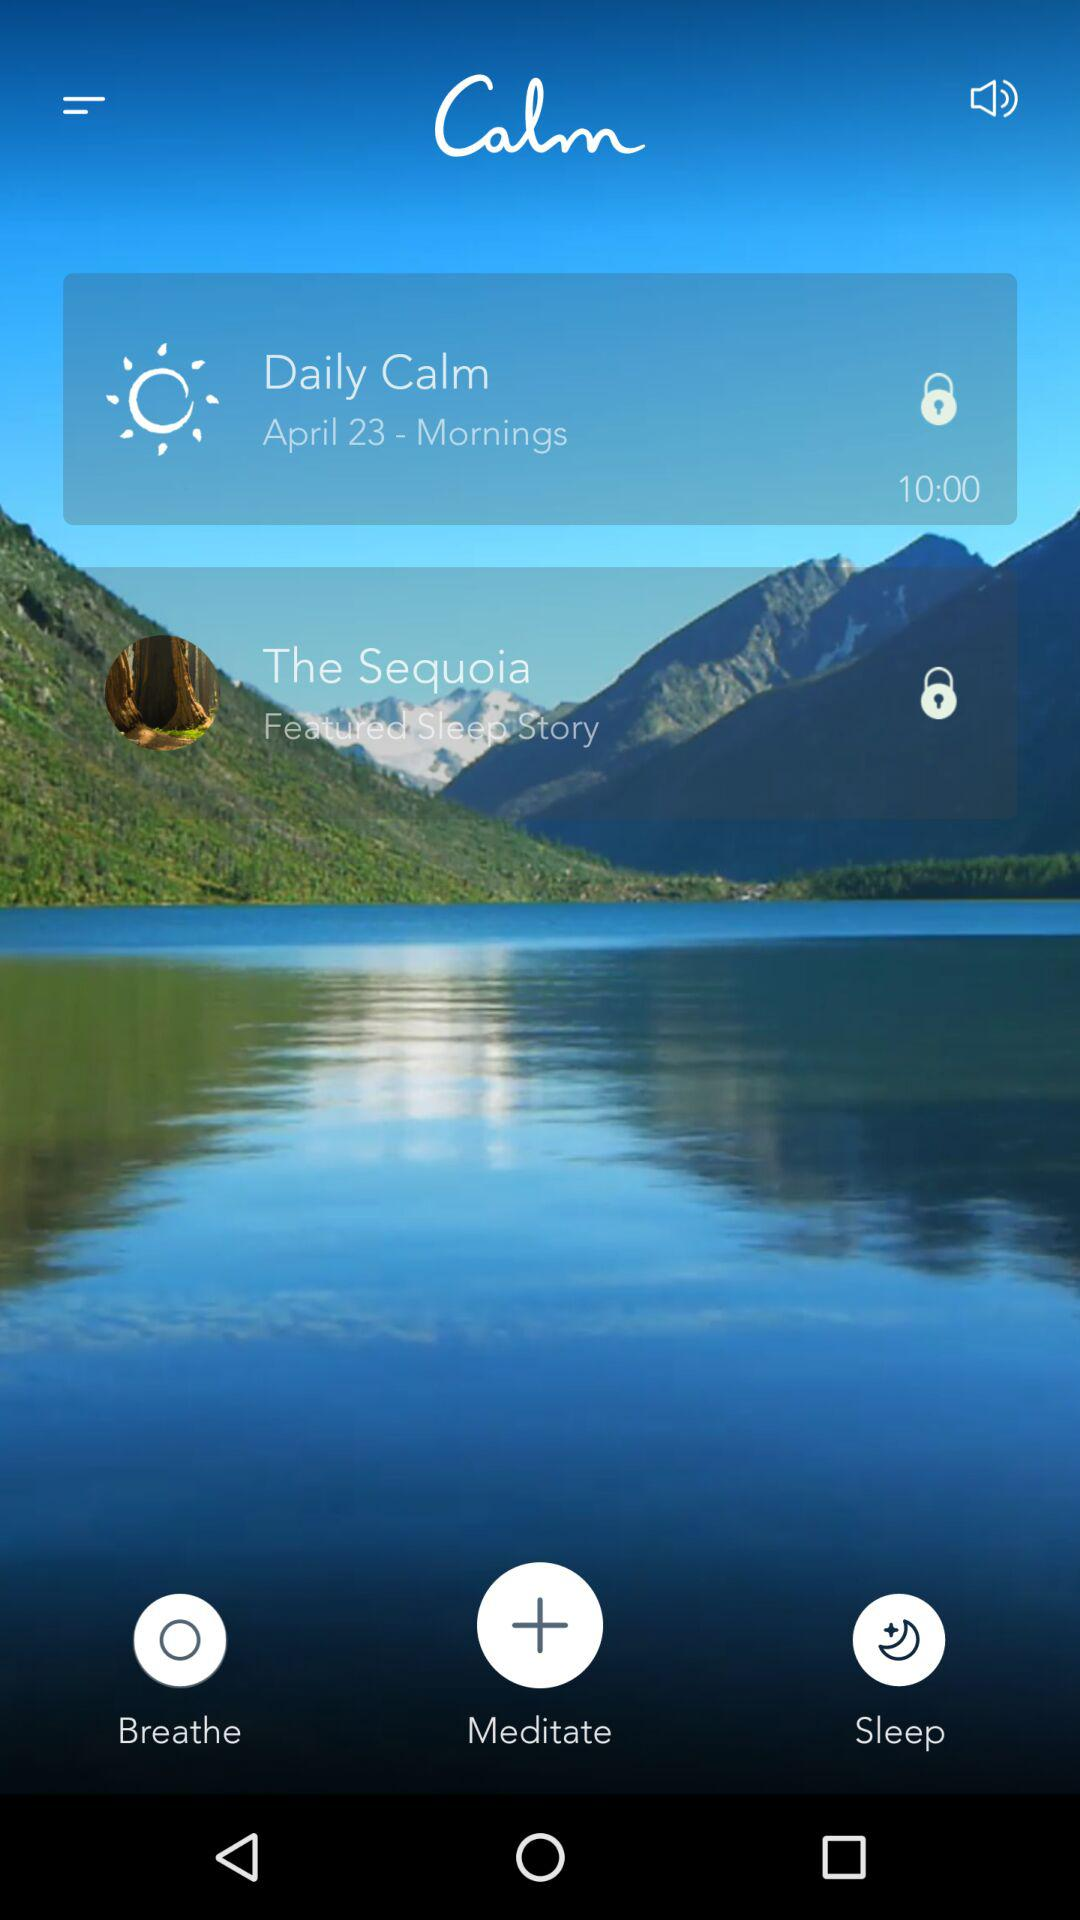How many items are locked?
Answer the question using a single word or phrase. 2 